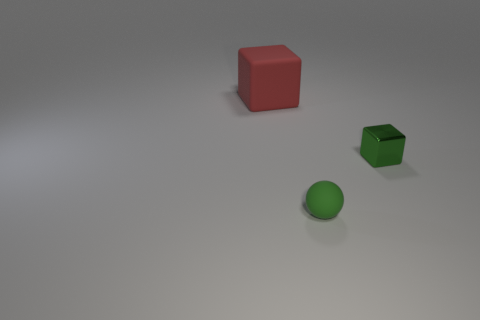Add 2 big red blocks. How many objects exist? 5 Subtract all cubes. How many objects are left? 1 Subtract 0 purple blocks. How many objects are left? 3 Subtract all large purple objects. Subtract all large red matte things. How many objects are left? 2 Add 3 tiny objects. How many tiny objects are left? 5 Add 1 small gray objects. How many small gray objects exist? 1 